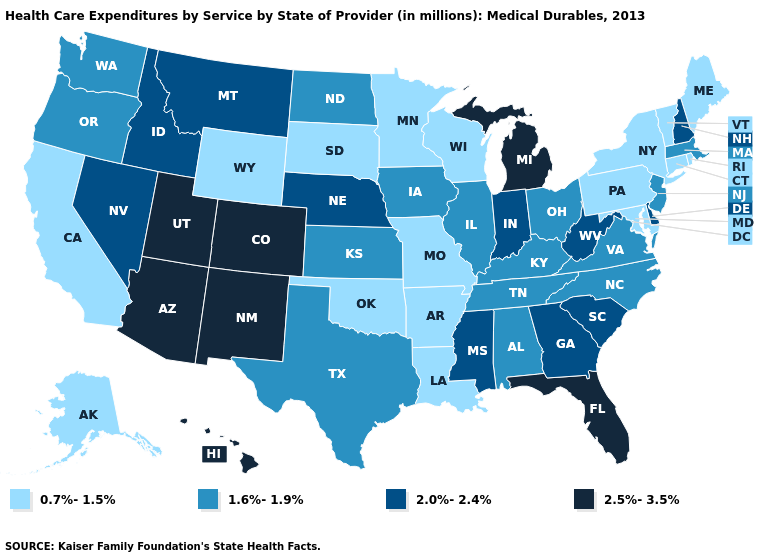Does Maine have the lowest value in the USA?
Be succinct. Yes. What is the highest value in the USA?
Give a very brief answer. 2.5%-3.5%. What is the value of Massachusetts?
Keep it brief. 1.6%-1.9%. Which states have the lowest value in the USA?
Be succinct. Alaska, Arkansas, California, Connecticut, Louisiana, Maine, Maryland, Minnesota, Missouri, New York, Oklahoma, Pennsylvania, Rhode Island, South Dakota, Vermont, Wisconsin, Wyoming. Name the states that have a value in the range 0.7%-1.5%?
Keep it brief. Alaska, Arkansas, California, Connecticut, Louisiana, Maine, Maryland, Minnesota, Missouri, New York, Oklahoma, Pennsylvania, Rhode Island, South Dakota, Vermont, Wisconsin, Wyoming. Name the states that have a value in the range 0.7%-1.5%?
Give a very brief answer. Alaska, Arkansas, California, Connecticut, Louisiana, Maine, Maryland, Minnesota, Missouri, New York, Oklahoma, Pennsylvania, Rhode Island, South Dakota, Vermont, Wisconsin, Wyoming. Which states hav the highest value in the Northeast?
Give a very brief answer. New Hampshire. What is the highest value in the West ?
Quick response, please. 2.5%-3.5%. What is the lowest value in the USA?
Write a very short answer. 0.7%-1.5%. Which states have the lowest value in the USA?
Write a very short answer. Alaska, Arkansas, California, Connecticut, Louisiana, Maine, Maryland, Minnesota, Missouri, New York, Oklahoma, Pennsylvania, Rhode Island, South Dakota, Vermont, Wisconsin, Wyoming. Name the states that have a value in the range 2.0%-2.4%?
Quick response, please. Delaware, Georgia, Idaho, Indiana, Mississippi, Montana, Nebraska, Nevada, New Hampshire, South Carolina, West Virginia. What is the highest value in states that border North Carolina?
Keep it brief. 2.0%-2.4%. Which states have the highest value in the USA?
Write a very short answer. Arizona, Colorado, Florida, Hawaii, Michigan, New Mexico, Utah. Among the states that border Indiana , does Michigan have the highest value?
Short answer required. Yes. Does Vermont have a lower value than Arkansas?
Be succinct. No. 